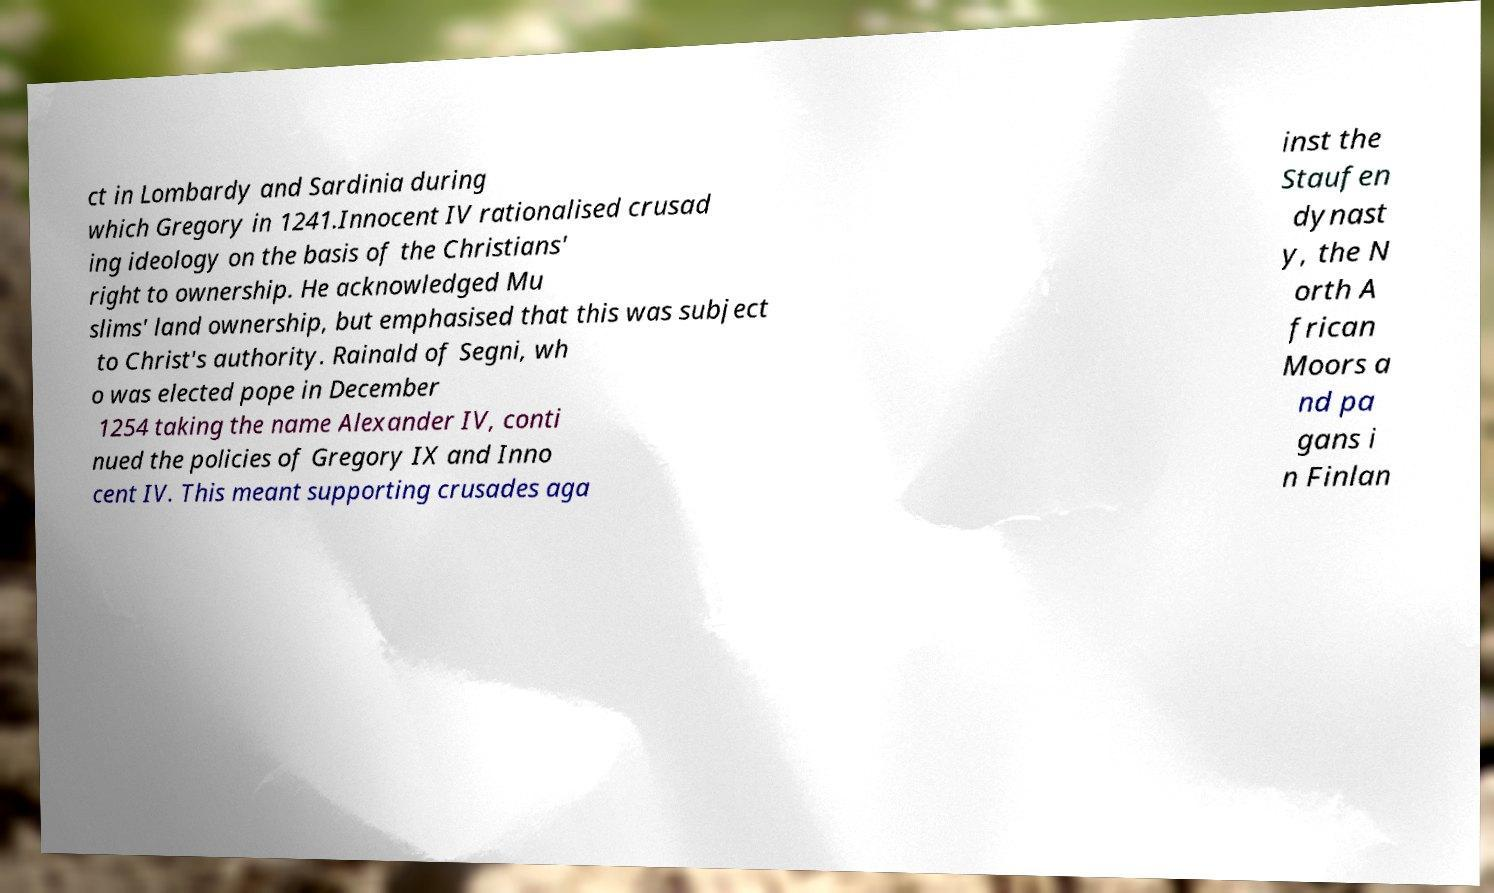Can you read and provide the text displayed in the image?This photo seems to have some interesting text. Can you extract and type it out for me? ct in Lombardy and Sardinia during which Gregory in 1241.Innocent IV rationalised crusad ing ideology on the basis of the Christians' right to ownership. He acknowledged Mu slims' land ownership, but emphasised that this was subject to Christ's authority. Rainald of Segni, wh o was elected pope in December 1254 taking the name Alexander IV, conti nued the policies of Gregory IX and Inno cent IV. This meant supporting crusades aga inst the Staufen dynast y, the N orth A frican Moors a nd pa gans i n Finlan 